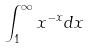<formula> <loc_0><loc_0><loc_500><loc_500>\int _ { 1 } ^ { \infty } x ^ { - x } d x</formula> 